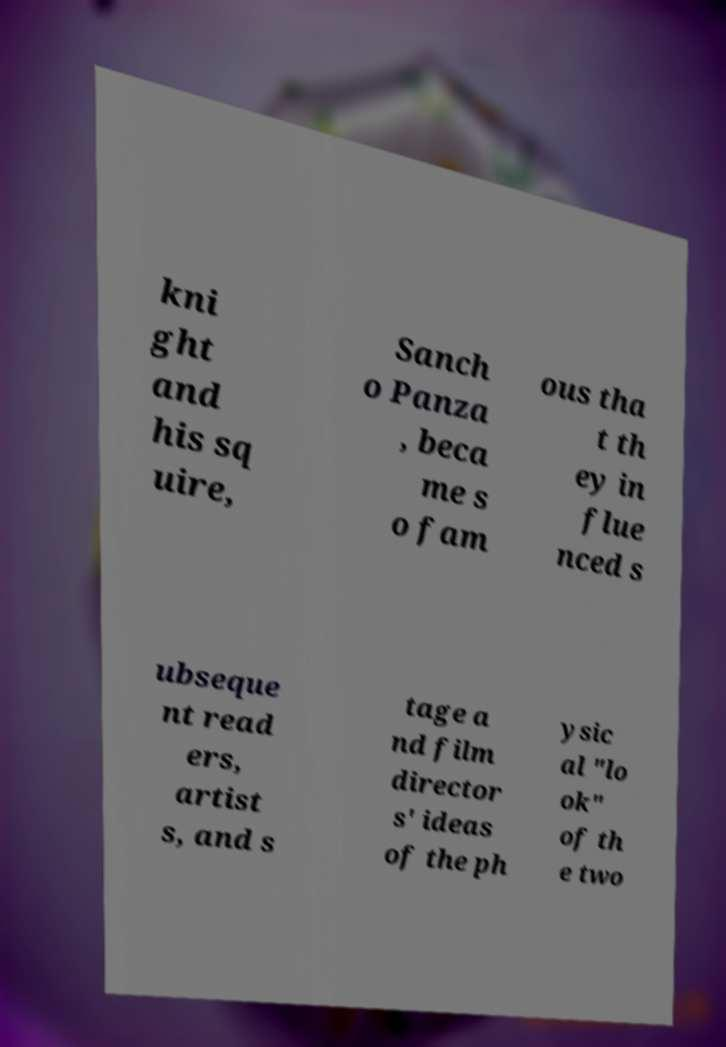Can you accurately transcribe the text from the provided image for me? kni ght and his sq uire, Sanch o Panza , beca me s o fam ous tha t th ey in flue nced s ubseque nt read ers, artist s, and s tage a nd film director s' ideas of the ph ysic al "lo ok" of th e two 